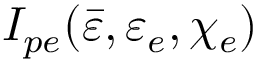<formula> <loc_0><loc_0><loc_500><loc_500>I _ { p e } ( \bar { \varepsilon } , \varepsilon _ { e } , \chi _ { e } )</formula> 